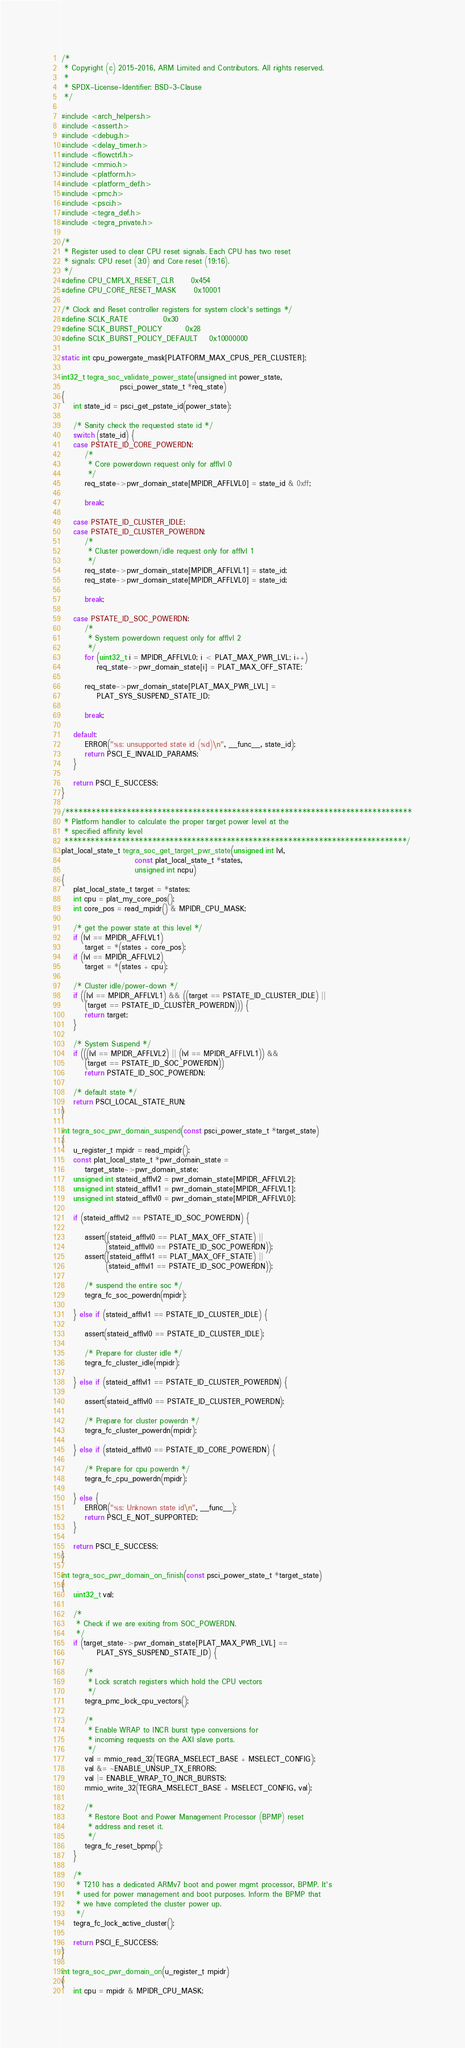Convert code to text. <code><loc_0><loc_0><loc_500><loc_500><_C_>/*
 * Copyright (c) 2015-2016, ARM Limited and Contributors. All rights reserved.
 *
 * SPDX-License-Identifier: BSD-3-Clause
 */

#include <arch_helpers.h>
#include <assert.h>
#include <debug.h>
#include <delay_timer.h>
#include <flowctrl.h>
#include <mmio.h>
#include <platform.h>
#include <platform_def.h>
#include <pmc.h>
#include <psci.h>
#include <tegra_def.h>
#include <tegra_private.h>

/*
 * Register used to clear CPU reset signals. Each CPU has two reset
 * signals: CPU reset (3:0) and Core reset (19:16).
 */
#define CPU_CMPLX_RESET_CLR		0x454
#define CPU_CORE_RESET_MASK		0x10001

/* Clock and Reset controller registers for system clock's settings */
#define SCLK_RATE			0x30
#define SCLK_BURST_POLICY		0x28
#define SCLK_BURST_POLICY_DEFAULT	0x10000000

static int cpu_powergate_mask[PLATFORM_MAX_CPUS_PER_CLUSTER];

int32_t tegra_soc_validate_power_state(unsigned int power_state,
					psci_power_state_t *req_state)
{
	int state_id = psci_get_pstate_id(power_state);

	/* Sanity check the requested state id */
	switch (state_id) {
	case PSTATE_ID_CORE_POWERDN:
		/*
		 * Core powerdown request only for afflvl 0
		 */
		req_state->pwr_domain_state[MPIDR_AFFLVL0] = state_id & 0xff;

		break;

	case PSTATE_ID_CLUSTER_IDLE:
	case PSTATE_ID_CLUSTER_POWERDN:
		/*
		 * Cluster powerdown/idle request only for afflvl 1
		 */
		req_state->pwr_domain_state[MPIDR_AFFLVL1] = state_id;
		req_state->pwr_domain_state[MPIDR_AFFLVL0] = state_id;

		break;

	case PSTATE_ID_SOC_POWERDN:
		/*
		 * System powerdown request only for afflvl 2
		 */
		for (uint32_t i = MPIDR_AFFLVL0; i < PLAT_MAX_PWR_LVL; i++)
			req_state->pwr_domain_state[i] = PLAT_MAX_OFF_STATE;

		req_state->pwr_domain_state[PLAT_MAX_PWR_LVL] =
			PLAT_SYS_SUSPEND_STATE_ID;

		break;

	default:
		ERROR("%s: unsupported state id (%d)\n", __func__, state_id);
		return PSCI_E_INVALID_PARAMS;
	}

	return PSCI_E_SUCCESS;
}

/*******************************************************************************
 * Platform handler to calculate the proper target power level at the
 * specified affinity level
 ******************************************************************************/
plat_local_state_t tegra_soc_get_target_pwr_state(unsigned int lvl,
					     const plat_local_state_t *states,
					     unsigned int ncpu)
{
	plat_local_state_t target = *states;
	int cpu = plat_my_core_pos();
	int core_pos = read_mpidr() & MPIDR_CPU_MASK;

	/* get the power state at this level */
	if (lvl == MPIDR_AFFLVL1)
		target = *(states + core_pos);
	if (lvl == MPIDR_AFFLVL2)
		target = *(states + cpu);

	/* Cluster idle/power-down */
	if ((lvl == MPIDR_AFFLVL1) && ((target == PSTATE_ID_CLUSTER_IDLE) ||
	    (target == PSTATE_ID_CLUSTER_POWERDN))) {
		return target;
	}

	/* System Suspend */
	if (((lvl == MPIDR_AFFLVL2) || (lvl == MPIDR_AFFLVL1)) &&
	    (target == PSTATE_ID_SOC_POWERDN))
		return PSTATE_ID_SOC_POWERDN;

	/* default state */
	return PSCI_LOCAL_STATE_RUN;
}

int tegra_soc_pwr_domain_suspend(const psci_power_state_t *target_state)
{
	u_register_t mpidr = read_mpidr();
	const plat_local_state_t *pwr_domain_state =
		target_state->pwr_domain_state;
	unsigned int stateid_afflvl2 = pwr_domain_state[MPIDR_AFFLVL2];
	unsigned int stateid_afflvl1 = pwr_domain_state[MPIDR_AFFLVL1];
	unsigned int stateid_afflvl0 = pwr_domain_state[MPIDR_AFFLVL0];

	if (stateid_afflvl2 == PSTATE_ID_SOC_POWERDN) {

		assert((stateid_afflvl0 == PLAT_MAX_OFF_STATE) ||
		       (stateid_afflvl0 == PSTATE_ID_SOC_POWERDN));
		assert((stateid_afflvl1 == PLAT_MAX_OFF_STATE) ||
		       (stateid_afflvl1 == PSTATE_ID_SOC_POWERDN));

		/* suspend the entire soc */
		tegra_fc_soc_powerdn(mpidr);

	} else if (stateid_afflvl1 == PSTATE_ID_CLUSTER_IDLE) {

		assert(stateid_afflvl0 == PSTATE_ID_CLUSTER_IDLE);

		/* Prepare for cluster idle */
		tegra_fc_cluster_idle(mpidr);

	} else if (stateid_afflvl1 == PSTATE_ID_CLUSTER_POWERDN) {

		assert(stateid_afflvl0 == PSTATE_ID_CLUSTER_POWERDN);

		/* Prepare for cluster powerdn */
		tegra_fc_cluster_powerdn(mpidr);

	} else if (stateid_afflvl0 == PSTATE_ID_CORE_POWERDN) {

		/* Prepare for cpu powerdn */
		tegra_fc_cpu_powerdn(mpidr);

	} else {
		ERROR("%s: Unknown state id\n", __func__);
		return PSCI_E_NOT_SUPPORTED;
	}

	return PSCI_E_SUCCESS;
}

int tegra_soc_pwr_domain_on_finish(const psci_power_state_t *target_state)
{
	uint32_t val;

	/*
	 * Check if we are exiting from SOC_POWERDN.
	 */
	if (target_state->pwr_domain_state[PLAT_MAX_PWR_LVL] ==
			PLAT_SYS_SUSPEND_STATE_ID) {

		/*
		 * Lock scratch registers which hold the CPU vectors
		 */
		tegra_pmc_lock_cpu_vectors();

		/*
		 * Enable WRAP to INCR burst type conversions for
		 * incoming requests on the AXI slave ports.
		 */
		val = mmio_read_32(TEGRA_MSELECT_BASE + MSELECT_CONFIG);
		val &= ~ENABLE_UNSUP_TX_ERRORS;
		val |= ENABLE_WRAP_TO_INCR_BURSTS;
		mmio_write_32(TEGRA_MSELECT_BASE + MSELECT_CONFIG, val);

		/*
		 * Restore Boot and Power Management Processor (BPMP) reset
		 * address and reset it.
		 */
		tegra_fc_reset_bpmp();
	}

	/*
	 * T210 has a dedicated ARMv7 boot and power mgmt processor, BPMP. It's
	 * used for power management and boot purposes. Inform the BPMP that
	 * we have completed the cluster power up.
	 */
	tegra_fc_lock_active_cluster();

	return PSCI_E_SUCCESS;
}

int tegra_soc_pwr_domain_on(u_register_t mpidr)
{
	int cpu = mpidr & MPIDR_CPU_MASK;</code> 